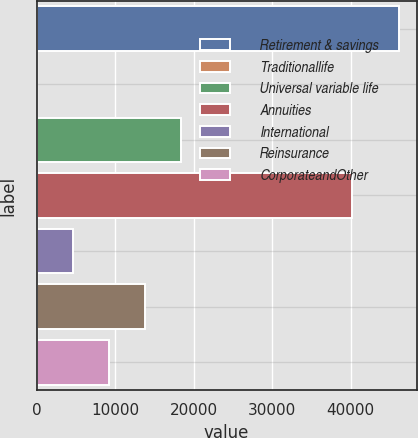Convert chart to OTSL. <chart><loc_0><loc_0><loc_500><loc_500><bar_chart><fcel>Retirement & savings<fcel>Traditionallife<fcel>Universal variable life<fcel>Annuities<fcel>International<fcel>Reinsurance<fcel>CorporateandOther<nl><fcel>46127<fcel>1<fcel>18451.4<fcel>40251<fcel>4613.6<fcel>13838.8<fcel>9226.2<nl></chart> 